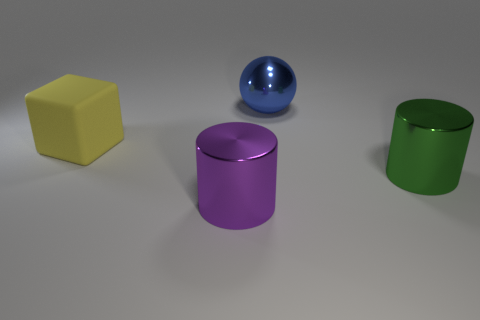Add 4 big blue rubber cubes. How many objects exist? 8 Subtract all spheres. How many objects are left? 3 Add 2 metal spheres. How many metal spheres are left? 3 Add 4 large objects. How many large objects exist? 8 Subtract 0 blue cubes. How many objects are left? 4 Subtract all big green cylinders. Subtract all big yellow cylinders. How many objects are left? 3 